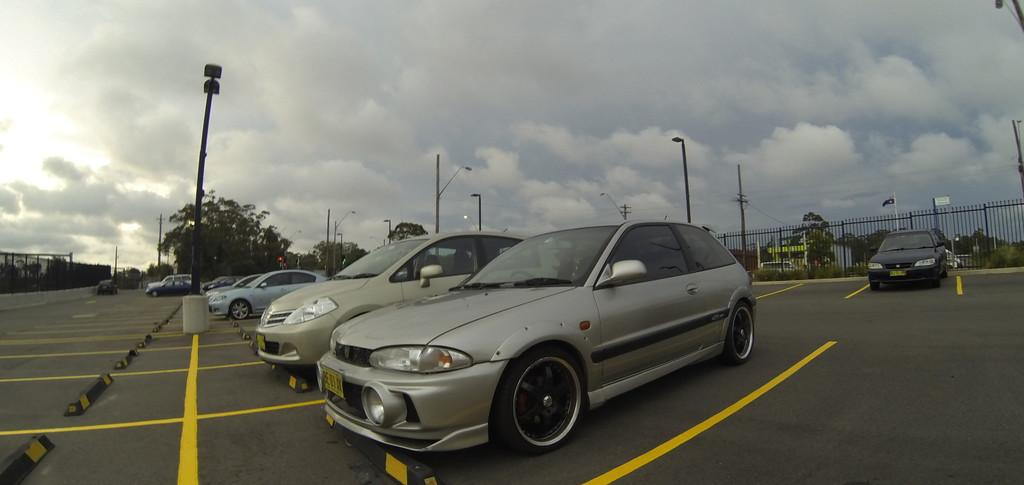What can be seen on the road in the image? There are cars on the road in the image. What structures are present in the image? There are poles and fences in the image. What type of vegetation is visible in the image? There are trees in the image. What is visible in the background of the image? The sky is visible in the background of the image. What is the weather like in the image? The presence of clouds in the sky suggests that it might be partly cloudy. Can you tell me how many horses are pulling the carriage in the image? There is no carriage or horses present in the image; it features cars on the road, poles, fences, trees, and a sky with clouds. What type of discussion is taking place between the trees in the image? There is no discussion taking place in the image; it is a still image of cars, poles, fences, trees, and a sky with clouds. 